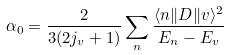Convert formula to latex. <formula><loc_0><loc_0><loc_500><loc_500>\alpha _ { 0 } = \frac { 2 } { 3 ( 2 j _ { v } + 1 ) } \sum _ { n } \frac { \langle n \| D \| v \rangle ^ { 2 } } { E _ { n } - E _ { v } }</formula> 